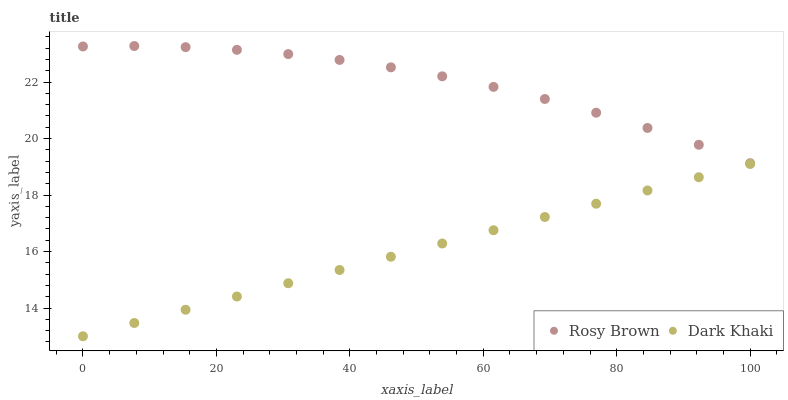Does Dark Khaki have the minimum area under the curve?
Answer yes or no. Yes. Does Rosy Brown have the maximum area under the curve?
Answer yes or no. Yes. Does Rosy Brown have the minimum area under the curve?
Answer yes or no. No. Is Dark Khaki the smoothest?
Answer yes or no. Yes. Is Rosy Brown the roughest?
Answer yes or no. Yes. Is Rosy Brown the smoothest?
Answer yes or no. No. Does Dark Khaki have the lowest value?
Answer yes or no. Yes. Does Rosy Brown have the lowest value?
Answer yes or no. No. Does Rosy Brown have the highest value?
Answer yes or no. Yes. Is Dark Khaki less than Rosy Brown?
Answer yes or no. Yes. Is Rosy Brown greater than Dark Khaki?
Answer yes or no. Yes. Does Dark Khaki intersect Rosy Brown?
Answer yes or no. No. 